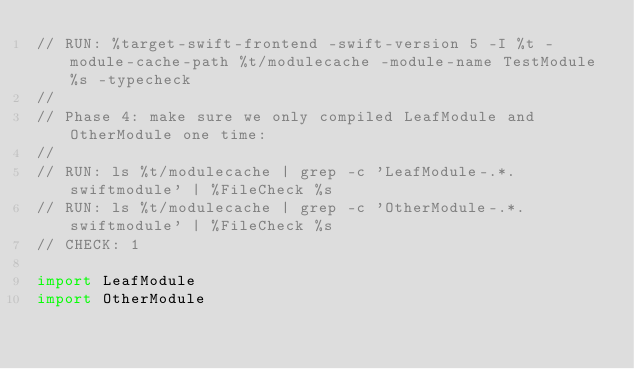Convert code to text. <code><loc_0><loc_0><loc_500><loc_500><_Swift_>// RUN: %target-swift-frontend -swift-version 5 -I %t -module-cache-path %t/modulecache -module-name TestModule %s -typecheck
//
// Phase 4: make sure we only compiled LeafModule and OtherModule one time:
//
// RUN: ls %t/modulecache | grep -c 'LeafModule-.*.swiftmodule' | %FileCheck %s
// RUN: ls %t/modulecache | grep -c 'OtherModule-.*.swiftmodule' | %FileCheck %s
// CHECK: 1

import LeafModule
import OtherModule
</code> 